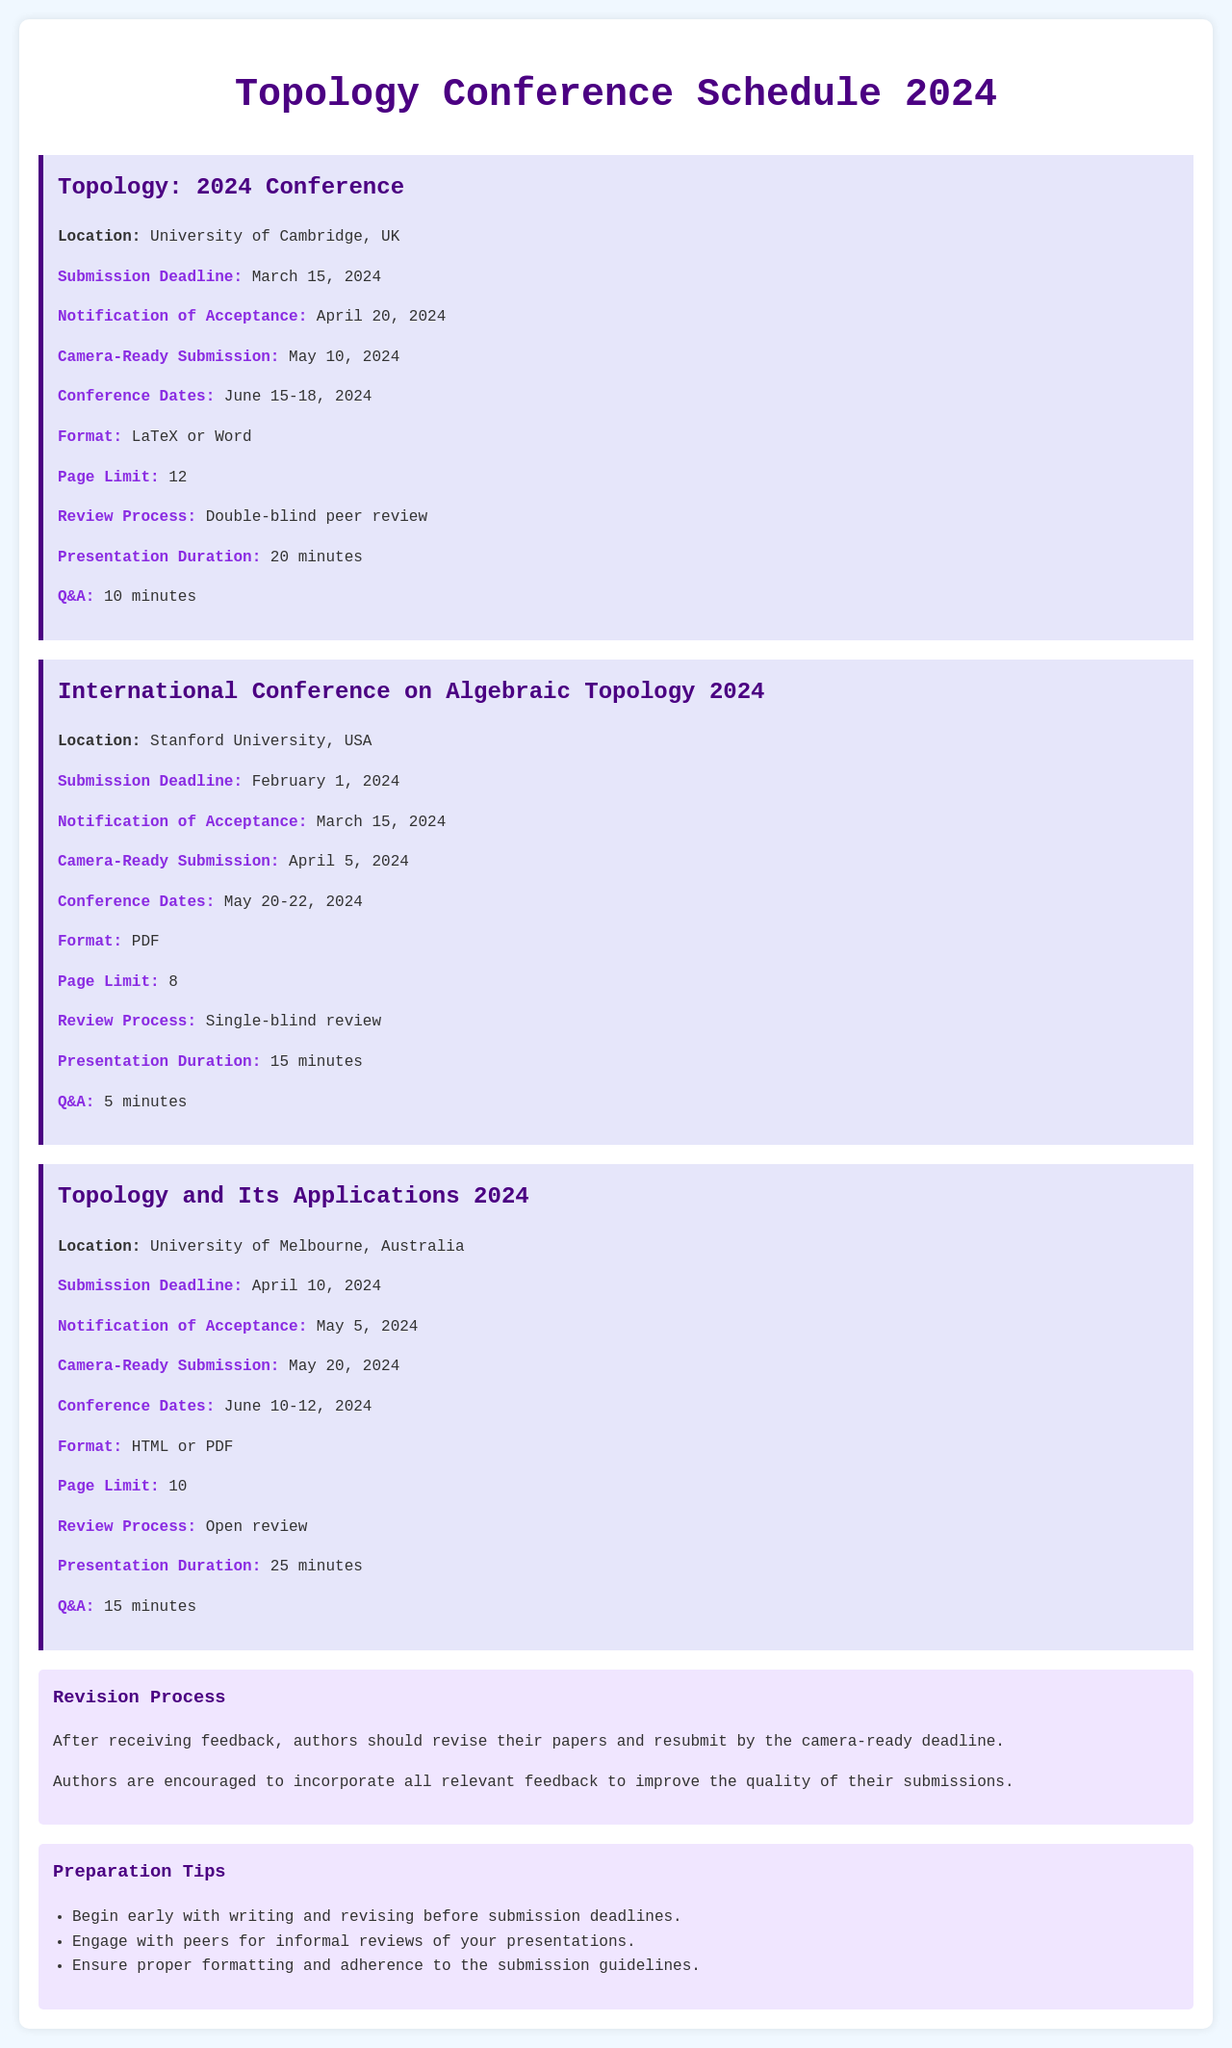What is the submission deadline for the Topology 2024 Conference? The submission deadline is listed in the document under the Topology: 2024 Conference section as March 15, 2024.
Answer: March 15, 2024 What is the page limit for submissions to the International Conference on Algebraic Topology 2024? The page limit can be found in the International Conference on Algebraic Topology 2024 section where it states 8 pages.
Answer: 8 When is the conference date for Topology and Its Applications 2024? The conference dates are specified under the Topology and Its Applications 2024 section, which states June 10-12, 2024.
Answer: June 10-12, 2024 What is the notification of acceptance date for the Topology 2024 Conference? The notification of acceptance date for the Topology: 2024 Conference is found in its section as April 20, 2024.
Answer: April 20, 2024 How long is the presentation duration for Topology and Its Applications 2024? The duration of presentations for Topology and Its Applications 2024 is listed under the presentation section as 25 minutes.
Answer: 25 minutes What type of review process does the Topology 2024 Conference use? The review process type is mentioned in the Topology: 2024 Conference guidelines as double-blind peer review.
Answer: Double-blind peer review What is the Q&A duration for presentations at the International Conference on Algebraic Topology 2024? The Q&A duration is specified under the presentation section of the International Conference on Algebraic Topology 2024 as 5 minutes.
Answer: 5 minutes What is suggested in the preparation tips regarding writing and revising? The preparation tips include an early start with writing and revising, as stated in the tips section.
Answer: Begin early What should authors do after receiving feedback on their submissions? The document states that authors should revise their papers and resubmit by the camera-ready deadline after receiving feedback.
Answer: Revise and resubmit 